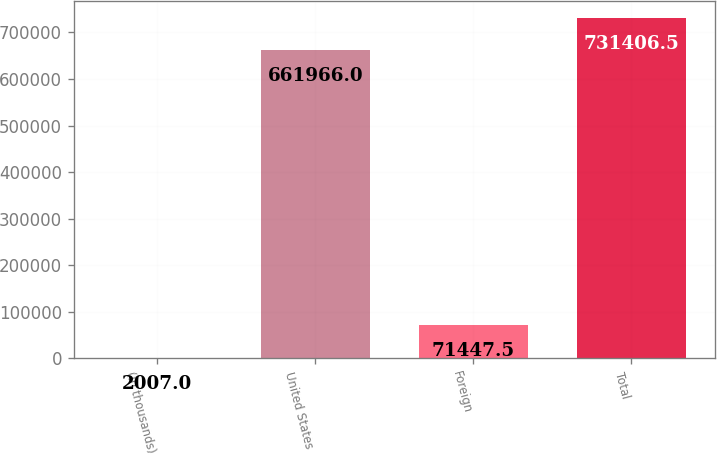<chart> <loc_0><loc_0><loc_500><loc_500><bar_chart><fcel>(In thousands)<fcel>United States<fcel>Foreign<fcel>Total<nl><fcel>2007<fcel>661966<fcel>71447.5<fcel>731406<nl></chart> 